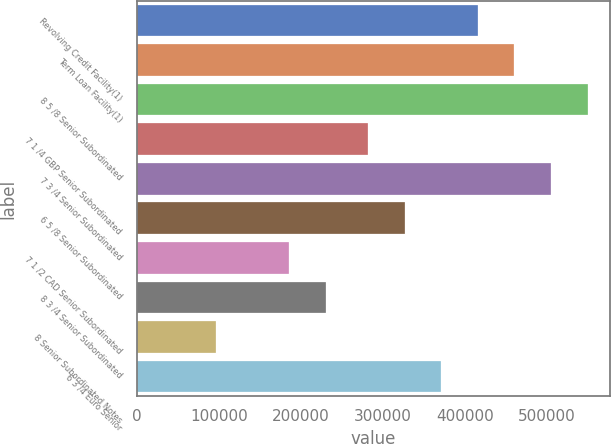<chart> <loc_0><loc_0><loc_500><loc_500><bar_chart><fcel>Revolving Credit Facility(1)<fcel>Term Loan Facility(1)<fcel>8 5 /8 Senior Subordinated<fcel>7 1 /4 GBP Senior Subordinated<fcel>7 3 /4 Senior Subordinated<fcel>6 5 /8 Senior Subordinated<fcel>7 1 /2 CAD Senior Subordinated<fcel>8 3 /4 Senior Subordinated<fcel>8 Senior Subordinated Notes<fcel>6 3 /4 Euro Senior<nl><fcel>415558<fcel>460204<fcel>549497<fcel>281619<fcel>504850<fcel>326265<fcel>185966<fcel>230612<fcel>96673.6<fcel>370912<nl></chart> 